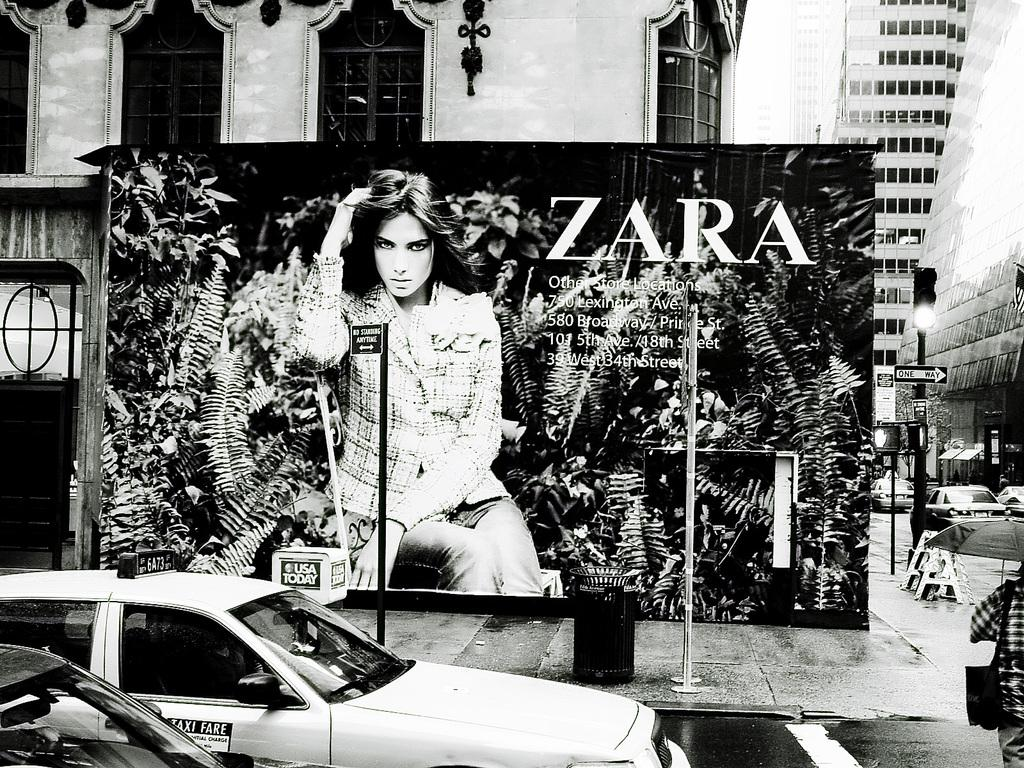What type of vehicles can be seen on the road in the image? There are cars on the road in the image. What structures are present in the image besides the cars? There are poles, buildings, and a poster in the image. How many chairs can be seen in the image? There are no chairs present in the image. What type of cord is being used to hold the poster in the image? There is no cord visible in the image; the poster is not shown to be attached to anything. 